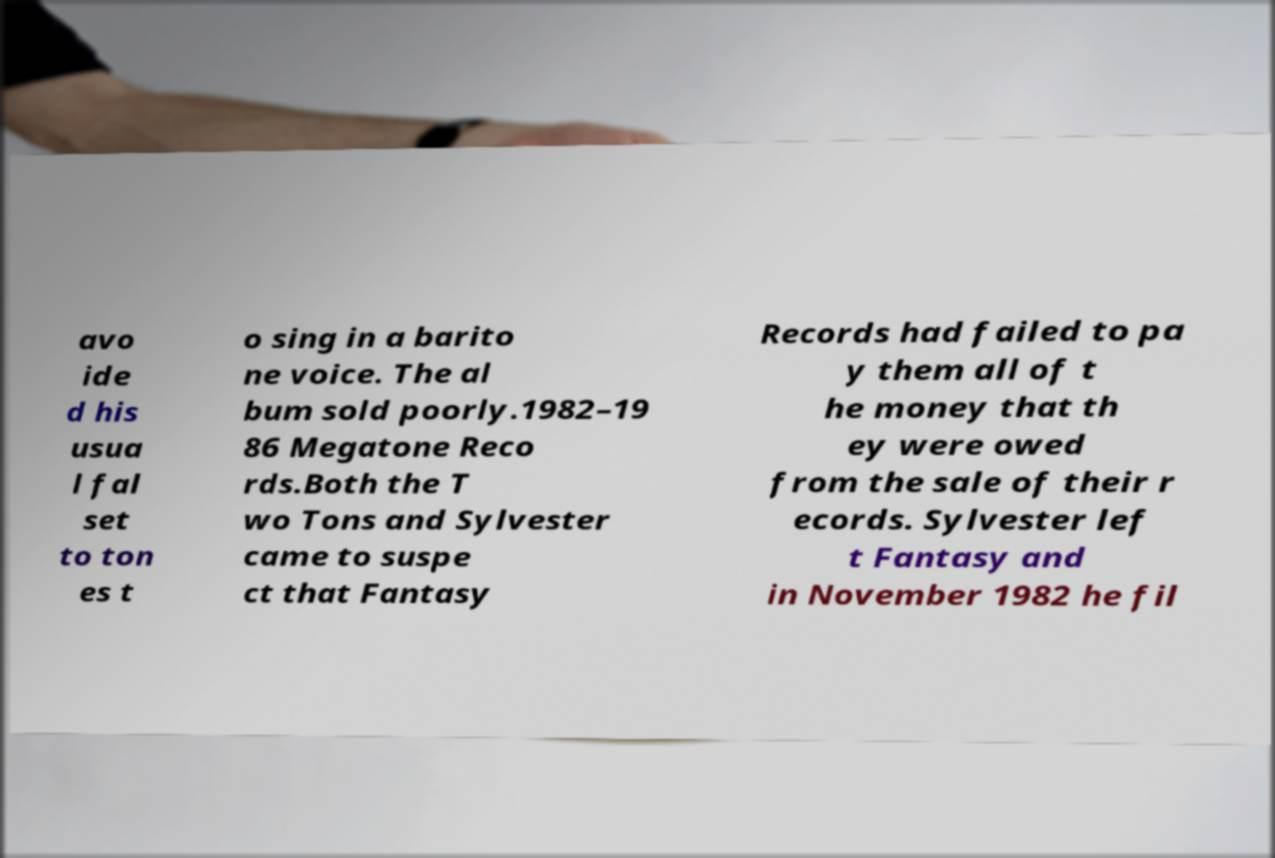Please identify and transcribe the text found in this image. avo ide d his usua l fal set to ton es t o sing in a barito ne voice. The al bum sold poorly.1982–19 86 Megatone Reco rds.Both the T wo Tons and Sylvester came to suspe ct that Fantasy Records had failed to pa y them all of t he money that th ey were owed from the sale of their r ecords. Sylvester lef t Fantasy and in November 1982 he fil 